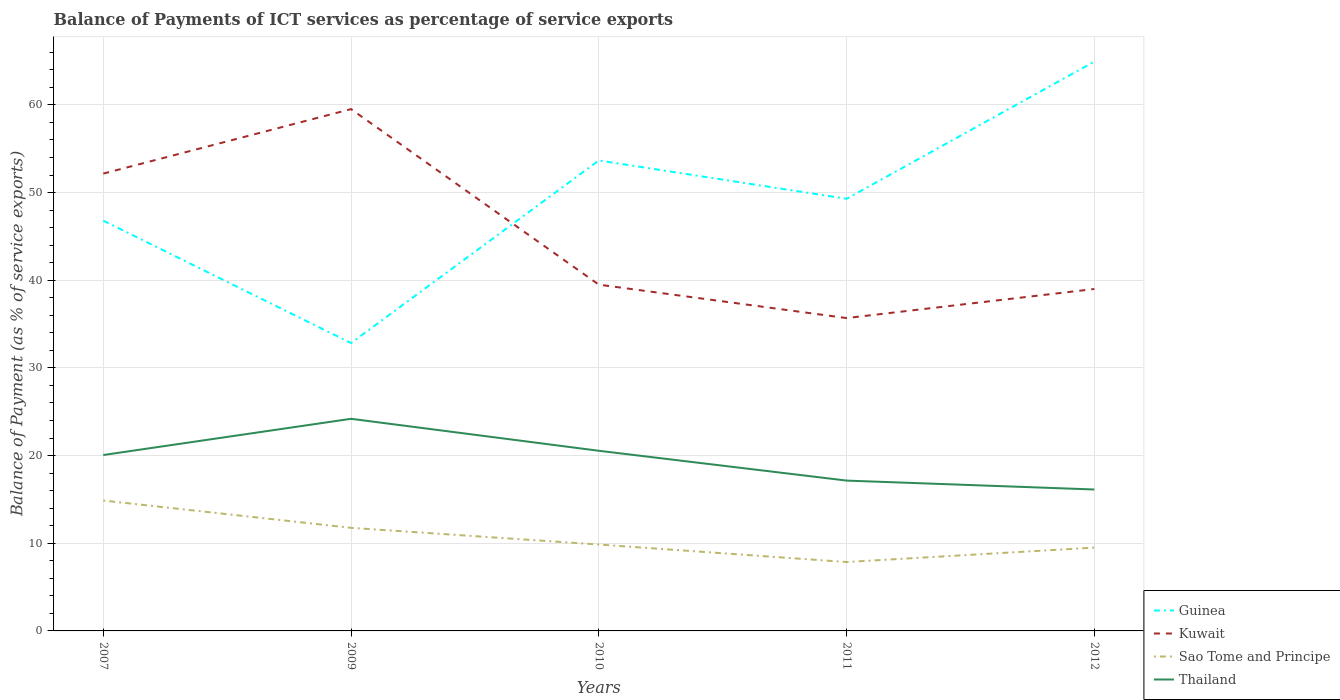How many different coloured lines are there?
Your answer should be compact. 4. Does the line corresponding to Kuwait intersect with the line corresponding to Sao Tome and Principe?
Provide a succinct answer. No. Across all years, what is the maximum balance of payments of ICT services in Kuwait?
Your answer should be very brief. 35.68. What is the total balance of payments of ICT services in Thailand in the graph?
Make the answer very short. -4.13. What is the difference between the highest and the second highest balance of payments of ICT services in Sao Tome and Principe?
Your answer should be compact. 7.01. What is the difference between the highest and the lowest balance of payments of ICT services in Kuwait?
Provide a short and direct response. 2. How many years are there in the graph?
Keep it short and to the point. 5. Does the graph contain any zero values?
Your answer should be compact. No. Where does the legend appear in the graph?
Your answer should be very brief. Bottom right. How many legend labels are there?
Provide a short and direct response. 4. How are the legend labels stacked?
Your response must be concise. Vertical. What is the title of the graph?
Your answer should be very brief. Balance of Payments of ICT services as percentage of service exports. Does "Algeria" appear as one of the legend labels in the graph?
Keep it short and to the point. No. What is the label or title of the Y-axis?
Offer a terse response. Balance of Payment (as % of service exports). What is the Balance of Payment (as % of service exports) in Guinea in 2007?
Your answer should be very brief. 46.8. What is the Balance of Payment (as % of service exports) in Kuwait in 2007?
Your answer should be very brief. 52.16. What is the Balance of Payment (as % of service exports) of Sao Tome and Principe in 2007?
Your answer should be very brief. 14.87. What is the Balance of Payment (as % of service exports) in Thailand in 2007?
Your response must be concise. 20.06. What is the Balance of Payment (as % of service exports) of Guinea in 2009?
Your answer should be very brief. 32.83. What is the Balance of Payment (as % of service exports) of Kuwait in 2009?
Keep it short and to the point. 59.52. What is the Balance of Payment (as % of service exports) of Sao Tome and Principe in 2009?
Your response must be concise. 11.76. What is the Balance of Payment (as % of service exports) in Thailand in 2009?
Ensure brevity in your answer.  24.19. What is the Balance of Payment (as % of service exports) in Guinea in 2010?
Offer a very short reply. 53.66. What is the Balance of Payment (as % of service exports) of Kuwait in 2010?
Your response must be concise. 39.5. What is the Balance of Payment (as % of service exports) in Sao Tome and Principe in 2010?
Offer a terse response. 9.85. What is the Balance of Payment (as % of service exports) in Thailand in 2010?
Make the answer very short. 20.55. What is the Balance of Payment (as % of service exports) in Guinea in 2011?
Your answer should be very brief. 49.29. What is the Balance of Payment (as % of service exports) in Kuwait in 2011?
Ensure brevity in your answer.  35.68. What is the Balance of Payment (as % of service exports) of Sao Tome and Principe in 2011?
Your answer should be compact. 7.86. What is the Balance of Payment (as % of service exports) in Thailand in 2011?
Offer a terse response. 17.15. What is the Balance of Payment (as % of service exports) of Guinea in 2012?
Your response must be concise. 64.94. What is the Balance of Payment (as % of service exports) in Kuwait in 2012?
Offer a terse response. 39. What is the Balance of Payment (as % of service exports) of Sao Tome and Principe in 2012?
Keep it short and to the point. 9.5. What is the Balance of Payment (as % of service exports) in Thailand in 2012?
Offer a terse response. 16.13. Across all years, what is the maximum Balance of Payment (as % of service exports) of Guinea?
Provide a short and direct response. 64.94. Across all years, what is the maximum Balance of Payment (as % of service exports) in Kuwait?
Your answer should be very brief. 59.52. Across all years, what is the maximum Balance of Payment (as % of service exports) of Sao Tome and Principe?
Make the answer very short. 14.87. Across all years, what is the maximum Balance of Payment (as % of service exports) of Thailand?
Offer a terse response. 24.19. Across all years, what is the minimum Balance of Payment (as % of service exports) in Guinea?
Offer a very short reply. 32.83. Across all years, what is the minimum Balance of Payment (as % of service exports) in Kuwait?
Offer a very short reply. 35.68. Across all years, what is the minimum Balance of Payment (as % of service exports) of Sao Tome and Principe?
Keep it short and to the point. 7.86. Across all years, what is the minimum Balance of Payment (as % of service exports) in Thailand?
Offer a very short reply. 16.13. What is the total Balance of Payment (as % of service exports) of Guinea in the graph?
Provide a succinct answer. 247.52. What is the total Balance of Payment (as % of service exports) in Kuwait in the graph?
Your answer should be very brief. 225.86. What is the total Balance of Payment (as % of service exports) in Sao Tome and Principe in the graph?
Provide a succinct answer. 53.85. What is the total Balance of Payment (as % of service exports) of Thailand in the graph?
Your response must be concise. 98.08. What is the difference between the Balance of Payment (as % of service exports) of Guinea in 2007 and that in 2009?
Ensure brevity in your answer.  13.96. What is the difference between the Balance of Payment (as % of service exports) of Kuwait in 2007 and that in 2009?
Offer a very short reply. -7.36. What is the difference between the Balance of Payment (as % of service exports) in Sao Tome and Principe in 2007 and that in 2009?
Your answer should be compact. 3.12. What is the difference between the Balance of Payment (as % of service exports) of Thailand in 2007 and that in 2009?
Your answer should be compact. -4.13. What is the difference between the Balance of Payment (as % of service exports) in Guinea in 2007 and that in 2010?
Offer a terse response. -6.86. What is the difference between the Balance of Payment (as % of service exports) of Kuwait in 2007 and that in 2010?
Your answer should be compact. 12.66. What is the difference between the Balance of Payment (as % of service exports) in Sao Tome and Principe in 2007 and that in 2010?
Ensure brevity in your answer.  5.02. What is the difference between the Balance of Payment (as % of service exports) of Thailand in 2007 and that in 2010?
Your response must be concise. -0.48. What is the difference between the Balance of Payment (as % of service exports) in Guinea in 2007 and that in 2011?
Offer a terse response. -2.49. What is the difference between the Balance of Payment (as % of service exports) of Kuwait in 2007 and that in 2011?
Your answer should be very brief. 16.48. What is the difference between the Balance of Payment (as % of service exports) of Sao Tome and Principe in 2007 and that in 2011?
Give a very brief answer. 7.01. What is the difference between the Balance of Payment (as % of service exports) of Thailand in 2007 and that in 2011?
Ensure brevity in your answer.  2.92. What is the difference between the Balance of Payment (as % of service exports) of Guinea in 2007 and that in 2012?
Your response must be concise. -18.14. What is the difference between the Balance of Payment (as % of service exports) in Kuwait in 2007 and that in 2012?
Offer a terse response. 13.16. What is the difference between the Balance of Payment (as % of service exports) in Sao Tome and Principe in 2007 and that in 2012?
Offer a terse response. 5.37. What is the difference between the Balance of Payment (as % of service exports) in Thailand in 2007 and that in 2012?
Give a very brief answer. 3.93. What is the difference between the Balance of Payment (as % of service exports) of Guinea in 2009 and that in 2010?
Your answer should be very brief. -20.83. What is the difference between the Balance of Payment (as % of service exports) of Kuwait in 2009 and that in 2010?
Provide a succinct answer. 20.02. What is the difference between the Balance of Payment (as % of service exports) of Sao Tome and Principe in 2009 and that in 2010?
Make the answer very short. 1.9. What is the difference between the Balance of Payment (as % of service exports) in Thailand in 2009 and that in 2010?
Offer a very short reply. 3.65. What is the difference between the Balance of Payment (as % of service exports) of Guinea in 2009 and that in 2011?
Provide a short and direct response. -16.45. What is the difference between the Balance of Payment (as % of service exports) in Kuwait in 2009 and that in 2011?
Keep it short and to the point. 23.83. What is the difference between the Balance of Payment (as % of service exports) of Sao Tome and Principe in 2009 and that in 2011?
Offer a very short reply. 3.9. What is the difference between the Balance of Payment (as % of service exports) in Thailand in 2009 and that in 2011?
Keep it short and to the point. 7.05. What is the difference between the Balance of Payment (as % of service exports) in Guinea in 2009 and that in 2012?
Your answer should be compact. -32.1. What is the difference between the Balance of Payment (as % of service exports) of Kuwait in 2009 and that in 2012?
Offer a very short reply. 20.52. What is the difference between the Balance of Payment (as % of service exports) in Sao Tome and Principe in 2009 and that in 2012?
Offer a terse response. 2.25. What is the difference between the Balance of Payment (as % of service exports) of Thailand in 2009 and that in 2012?
Keep it short and to the point. 8.06. What is the difference between the Balance of Payment (as % of service exports) in Guinea in 2010 and that in 2011?
Your answer should be very brief. 4.37. What is the difference between the Balance of Payment (as % of service exports) in Kuwait in 2010 and that in 2011?
Keep it short and to the point. 3.81. What is the difference between the Balance of Payment (as % of service exports) in Sao Tome and Principe in 2010 and that in 2011?
Your answer should be very brief. 1.99. What is the difference between the Balance of Payment (as % of service exports) of Thailand in 2010 and that in 2011?
Offer a terse response. 3.4. What is the difference between the Balance of Payment (as % of service exports) in Guinea in 2010 and that in 2012?
Ensure brevity in your answer.  -11.28. What is the difference between the Balance of Payment (as % of service exports) in Kuwait in 2010 and that in 2012?
Provide a succinct answer. 0.5. What is the difference between the Balance of Payment (as % of service exports) of Sao Tome and Principe in 2010 and that in 2012?
Ensure brevity in your answer.  0.35. What is the difference between the Balance of Payment (as % of service exports) of Thailand in 2010 and that in 2012?
Provide a succinct answer. 4.42. What is the difference between the Balance of Payment (as % of service exports) of Guinea in 2011 and that in 2012?
Keep it short and to the point. -15.65. What is the difference between the Balance of Payment (as % of service exports) in Kuwait in 2011 and that in 2012?
Your response must be concise. -3.32. What is the difference between the Balance of Payment (as % of service exports) of Sao Tome and Principe in 2011 and that in 2012?
Give a very brief answer. -1.64. What is the difference between the Balance of Payment (as % of service exports) in Thailand in 2011 and that in 2012?
Keep it short and to the point. 1.02. What is the difference between the Balance of Payment (as % of service exports) in Guinea in 2007 and the Balance of Payment (as % of service exports) in Kuwait in 2009?
Give a very brief answer. -12.72. What is the difference between the Balance of Payment (as % of service exports) in Guinea in 2007 and the Balance of Payment (as % of service exports) in Sao Tome and Principe in 2009?
Offer a terse response. 35.04. What is the difference between the Balance of Payment (as % of service exports) in Guinea in 2007 and the Balance of Payment (as % of service exports) in Thailand in 2009?
Ensure brevity in your answer.  22.6. What is the difference between the Balance of Payment (as % of service exports) in Kuwait in 2007 and the Balance of Payment (as % of service exports) in Sao Tome and Principe in 2009?
Your answer should be very brief. 40.4. What is the difference between the Balance of Payment (as % of service exports) of Kuwait in 2007 and the Balance of Payment (as % of service exports) of Thailand in 2009?
Provide a succinct answer. 27.97. What is the difference between the Balance of Payment (as % of service exports) of Sao Tome and Principe in 2007 and the Balance of Payment (as % of service exports) of Thailand in 2009?
Your answer should be compact. -9.32. What is the difference between the Balance of Payment (as % of service exports) in Guinea in 2007 and the Balance of Payment (as % of service exports) in Kuwait in 2010?
Keep it short and to the point. 7.3. What is the difference between the Balance of Payment (as % of service exports) of Guinea in 2007 and the Balance of Payment (as % of service exports) of Sao Tome and Principe in 2010?
Your answer should be compact. 36.94. What is the difference between the Balance of Payment (as % of service exports) in Guinea in 2007 and the Balance of Payment (as % of service exports) in Thailand in 2010?
Offer a terse response. 26.25. What is the difference between the Balance of Payment (as % of service exports) in Kuwait in 2007 and the Balance of Payment (as % of service exports) in Sao Tome and Principe in 2010?
Offer a very short reply. 42.31. What is the difference between the Balance of Payment (as % of service exports) in Kuwait in 2007 and the Balance of Payment (as % of service exports) in Thailand in 2010?
Offer a terse response. 31.61. What is the difference between the Balance of Payment (as % of service exports) in Sao Tome and Principe in 2007 and the Balance of Payment (as % of service exports) in Thailand in 2010?
Provide a short and direct response. -5.67. What is the difference between the Balance of Payment (as % of service exports) in Guinea in 2007 and the Balance of Payment (as % of service exports) in Kuwait in 2011?
Ensure brevity in your answer.  11.11. What is the difference between the Balance of Payment (as % of service exports) in Guinea in 2007 and the Balance of Payment (as % of service exports) in Sao Tome and Principe in 2011?
Keep it short and to the point. 38.94. What is the difference between the Balance of Payment (as % of service exports) in Guinea in 2007 and the Balance of Payment (as % of service exports) in Thailand in 2011?
Provide a succinct answer. 29.65. What is the difference between the Balance of Payment (as % of service exports) in Kuwait in 2007 and the Balance of Payment (as % of service exports) in Sao Tome and Principe in 2011?
Your answer should be compact. 44.3. What is the difference between the Balance of Payment (as % of service exports) of Kuwait in 2007 and the Balance of Payment (as % of service exports) of Thailand in 2011?
Your answer should be very brief. 35.01. What is the difference between the Balance of Payment (as % of service exports) in Sao Tome and Principe in 2007 and the Balance of Payment (as % of service exports) in Thailand in 2011?
Your answer should be very brief. -2.27. What is the difference between the Balance of Payment (as % of service exports) in Guinea in 2007 and the Balance of Payment (as % of service exports) in Kuwait in 2012?
Provide a succinct answer. 7.8. What is the difference between the Balance of Payment (as % of service exports) in Guinea in 2007 and the Balance of Payment (as % of service exports) in Sao Tome and Principe in 2012?
Offer a very short reply. 37.29. What is the difference between the Balance of Payment (as % of service exports) in Guinea in 2007 and the Balance of Payment (as % of service exports) in Thailand in 2012?
Ensure brevity in your answer.  30.67. What is the difference between the Balance of Payment (as % of service exports) of Kuwait in 2007 and the Balance of Payment (as % of service exports) of Sao Tome and Principe in 2012?
Offer a very short reply. 42.66. What is the difference between the Balance of Payment (as % of service exports) in Kuwait in 2007 and the Balance of Payment (as % of service exports) in Thailand in 2012?
Make the answer very short. 36.03. What is the difference between the Balance of Payment (as % of service exports) of Sao Tome and Principe in 2007 and the Balance of Payment (as % of service exports) of Thailand in 2012?
Offer a terse response. -1.26. What is the difference between the Balance of Payment (as % of service exports) in Guinea in 2009 and the Balance of Payment (as % of service exports) in Kuwait in 2010?
Your answer should be compact. -6.66. What is the difference between the Balance of Payment (as % of service exports) of Guinea in 2009 and the Balance of Payment (as % of service exports) of Sao Tome and Principe in 2010?
Provide a short and direct response. 22.98. What is the difference between the Balance of Payment (as % of service exports) of Guinea in 2009 and the Balance of Payment (as % of service exports) of Thailand in 2010?
Ensure brevity in your answer.  12.29. What is the difference between the Balance of Payment (as % of service exports) of Kuwait in 2009 and the Balance of Payment (as % of service exports) of Sao Tome and Principe in 2010?
Your answer should be very brief. 49.66. What is the difference between the Balance of Payment (as % of service exports) of Kuwait in 2009 and the Balance of Payment (as % of service exports) of Thailand in 2010?
Keep it short and to the point. 38.97. What is the difference between the Balance of Payment (as % of service exports) in Sao Tome and Principe in 2009 and the Balance of Payment (as % of service exports) in Thailand in 2010?
Your answer should be compact. -8.79. What is the difference between the Balance of Payment (as % of service exports) in Guinea in 2009 and the Balance of Payment (as % of service exports) in Kuwait in 2011?
Provide a succinct answer. -2.85. What is the difference between the Balance of Payment (as % of service exports) of Guinea in 2009 and the Balance of Payment (as % of service exports) of Sao Tome and Principe in 2011?
Your response must be concise. 24.98. What is the difference between the Balance of Payment (as % of service exports) of Guinea in 2009 and the Balance of Payment (as % of service exports) of Thailand in 2011?
Your response must be concise. 15.69. What is the difference between the Balance of Payment (as % of service exports) of Kuwait in 2009 and the Balance of Payment (as % of service exports) of Sao Tome and Principe in 2011?
Provide a short and direct response. 51.66. What is the difference between the Balance of Payment (as % of service exports) of Kuwait in 2009 and the Balance of Payment (as % of service exports) of Thailand in 2011?
Ensure brevity in your answer.  42.37. What is the difference between the Balance of Payment (as % of service exports) in Sao Tome and Principe in 2009 and the Balance of Payment (as % of service exports) in Thailand in 2011?
Your answer should be compact. -5.39. What is the difference between the Balance of Payment (as % of service exports) of Guinea in 2009 and the Balance of Payment (as % of service exports) of Kuwait in 2012?
Ensure brevity in your answer.  -6.17. What is the difference between the Balance of Payment (as % of service exports) of Guinea in 2009 and the Balance of Payment (as % of service exports) of Sao Tome and Principe in 2012?
Offer a very short reply. 23.33. What is the difference between the Balance of Payment (as % of service exports) of Guinea in 2009 and the Balance of Payment (as % of service exports) of Thailand in 2012?
Keep it short and to the point. 16.7. What is the difference between the Balance of Payment (as % of service exports) of Kuwait in 2009 and the Balance of Payment (as % of service exports) of Sao Tome and Principe in 2012?
Keep it short and to the point. 50.01. What is the difference between the Balance of Payment (as % of service exports) of Kuwait in 2009 and the Balance of Payment (as % of service exports) of Thailand in 2012?
Offer a very short reply. 43.39. What is the difference between the Balance of Payment (as % of service exports) in Sao Tome and Principe in 2009 and the Balance of Payment (as % of service exports) in Thailand in 2012?
Offer a very short reply. -4.37. What is the difference between the Balance of Payment (as % of service exports) in Guinea in 2010 and the Balance of Payment (as % of service exports) in Kuwait in 2011?
Your answer should be compact. 17.98. What is the difference between the Balance of Payment (as % of service exports) of Guinea in 2010 and the Balance of Payment (as % of service exports) of Sao Tome and Principe in 2011?
Your response must be concise. 45.8. What is the difference between the Balance of Payment (as % of service exports) of Guinea in 2010 and the Balance of Payment (as % of service exports) of Thailand in 2011?
Offer a terse response. 36.51. What is the difference between the Balance of Payment (as % of service exports) of Kuwait in 2010 and the Balance of Payment (as % of service exports) of Sao Tome and Principe in 2011?
Ensure brevity in your answer.  31.64. What is the difference between the Balance of Payment (as % of service exports) in Kuwait in 2010 and the Balance of Payment (as % of service exports) in Thailand in 2011?
Provide a short and direct response. 22.35. What is the difference between the Balance of Payment (as % of service exports) of Sao Tome and Principe in 2010 and the Balance of Payment (as % of service exports) of Thailand in 2011?
Your response must be concise. -7.29. What is the difference between the Balance of Payment (as % of service exports) of Guinea in 2010 and the Balance of Payment (as % of service exports) of Kuwait in 2012?
Make the answer very short. 14.66. What is the difference between the Balance of Payment (as % of service exports) in Guinea in 2010 and the Balance of Payment (as % of service exports) in Sao Tome and Principe in 2012?
Offer a terse response. 44.16. What is the difference between the Balance of Payment (as % of service exports) of Guinea in 2010 and the Balance of Payment (as % of service exports) of Thailand in 2012?
Your response must be concise. 37.53. What is the difference between the Balance of Payment (as % of service exports) in Kuwait in 2010 and the Balance of Payment (as % of service exports) in Sao Tome and Principe in 2012?
Your answer should be compact. 29.99. What is the difference between the Balance of Payment (as % of service exports) of Kuwait in 2010 and the Balance of Payment (as % of service exports) of Thailand in 2012?
Provide a short and direct response. 23.37. What is the difference between the Balance of Payment (as % of service exports) in Sao Tome and Principe in 2010 and the Balance of Payment (as % of service exports) in Thailand in 2012?
Offer a very short reply. -6.28. What is the difference between the Balance of Payment (as % of service exports) in Guinea in 2011 and the Balance of Payment (as % of service exports) in Kuwait in 2012?
Offer a very short reply. 10.29. What is the difference between the Balance of Payment (as % of service exports) in Guinea in 2011 and the Balance of Payment (as % of service exports) in Sao Tome and Principe in 2012?
Give a very brief answer. 39.79. What is the difference between the Balance of Payment (as % of service exports) in Guinea in 2011 and the Balance of Payment (as % of service exports) in Thailand in 2012?
Your answer should be compact. 33.16. What is the difference between the Balance of Payment (as % of service exports) of Kuwait in 2011 and the Balance of Payment (as % of service exports) of Sao Tome and Principe in 2012?
Offer a terse response. 26.18. What is the difference between the Balance of Payment (as % of service exports) of Kuwait in 2011 and the Balance of Payment (as % of service exports) of Thailand in 2012?
Your answer should be compact. 19.55. What is the difference between the Balance of Payment (as % of service exports) of Sao Tome and Principe in 2011 and the Balance of Payment (as % of service exports) of Thailand in 2012?
Provide a short and direct response. -8.27. What is the average Balance of Payment (as % of service exports) of Guinea per year?
Offer a very short reply. 49.5. What is the average Balance of Payment (as % of service exports) of Kuwait per year?
Offer a terse response. 45.17. What is the average Balance of Payment (as % of service exports) of Sao Tome and Principe per year?
Provide a short and direct response. 10.77. What is the average Balance of Payment (as % of service exports) of Thailand per year?
Keep it short and to the point. 19.62. In the year 2007, what is the difference between the Balance of Payment (as % of service exports) of Guinea and Balance of Payment (as % of service exports) of Kuwait?
Keep it short and to the point. -5.36. In the year 2007, what is the difference between the Balance of Payment (as % of service exports) in Guinea and Balance of Payment (as % of service exports) in Sao Tome and Principe?
Ensure brevity in your answer.  31.92. In the year 2007, what is the difference between the Balance of Payment (as % of service exports) of Guinea and Balance of Payment (as % of service exports) of Thailand?
Keep it short and to the point. 26.73. In the year 2007, what is the difference between the Balance of Payment (as % of service exports) in Kuwait and Balance of Payment (as % of service exports) in Sao Tome and Principe?
Your answer should be compact. 37.29. In the year 2007, what is the difference between the Balance of Payment (as % of service exports) in Kuwait and Balance of Payment (as % of service exports) in Thailand?
Provide a short and direct response. 32.1. In the year 2007, what is the difference between the Balance of Payment (as % of service exports) of Sao Tome and Principe and Balance of Payment (as % of service exports) of Thailand?
Provide a succinct answer. -5.19. In the year 2009, what is the difference between the Balance of Payment (as % of service exports) of Guinea and Balance of Payment (as % of service exports) of Kuwait?
Your answer should be compact. -26.68. In the year 2009, what is the difference between the Balance of Payment (as % of service exports) in Guinea and Balance of Payment (as % of service exports) in Sao Tome and Principe?
Offer a very short reply. 21.08. In the year 2009, what is the difference between the Balance of Payment (as % of service exports) in Guinea and Balance of Payment (as % of service exports) in Thailand?
Your answer should be very brief. 8.64. In the year 2009, what is the difference between the Balance of Payment (as % of service exports) of Kuwait and Balance of Payment (as % of service exports) of Sao Tome and Principe?
Offer a terse response. 47.76. In the year 2009, what is the difference between the Balance of Payment (as % of service exports) in Kuwait and Balance of Payment (as % of service exports) in Thailand?
Provide a succinct answer. 35.32. In the year 2009, what is the difference between the Balance of Payment (as % of service exports) of Sao Tome and Principe and Balance of Payment (as % of service exports) of Thailand?
Make the answer very short. -12.44. In the year 2010, what is the difference between the Balance of Payment (as % of service exports) of Guinea and Balance of Payment (as % of service exports) of Kuwait?
Your answer should be compact. 14.16. In the year 2010, what is the difference between the Balance of Payment (as % of service exports) of Guinea and Balance of Payment (as % of service exports) of Sao Tome and Principe?
Make the answer very short. 43.81. In the year 2010, what is the difference between the Balance of Payment (as % of service exports) in Guinea and Balance of Payment (as % of service exports) in Thailand?
Make the answer very short. 33.11. In the year 2010, what is the difference between the Balance of Payment (as % of service exports) in Kuwait and Balance of Payment (as % of service exports) in Sao Tome and Principe?
Your response must be concise. 29.64. In the year 2010, what is the difference between the Balance of Payment (as % of service exports) in Kuwait and Balance of Payment (as % of service exports) in Thailand?
Offer a very short reply. 18.95. In the year 2010, what is the difference between the Balance of Payment (as % of service exports) of Sao Tome and Principe and Balance of Payment (as % of service exports) of Thailand?
Give a very brief answer. -10.69. In the year 2011, what is the difference between the Balance of Payment (as % of service exports) in Guinea and Balance of Payment (as % of service exports) in Kuwait?
Provide a succinct answer. 13.61. In the year 2011, what is the difference between the Balance of Payment (as % of service exports) in Guinea and Balance of Payment (as % of service exports) in Sao Tome and Principe?
Your answer should be compact. 41.43. In the year 2011, what is the difference between the Balance of Payment (as % of service exports) of Guinea and Balance of Payment (as % of service exports) of Thailand?
Ensure brevity in your answer.  32.14. In the year 2011, what is the difference between the Balance of Payment (as % of service exports) of Kuwait and Balance of Payment (as % of service exports) of Sao Tome and Principe?
Your answer should be compact. 27.82. In the year 2011, what is the difference between the Balance of Payment (as % of service exports) of Kuwait and Balance of Payment (as % of service exports) of Thailand?
Your answer should be very brief. 18.54. In the year 2011, what is the difference between the Balance of Payment (as % of service exports) in Sao Tome and Principe and Balance of Payment (as % of service exports) in Thailand?
Offer a terse response. -9.29. In the year 2012, what is the difference between the Balance of Payment (as % of service exports) of Guinea and Balance of Payment (as % of service exports) of Kuwait?
Keep it short and to the point. 25.94. In the year 2012, what is the difference between the Balance of Payment (as % of service exports) of Guinea and Balance of Payment (as % of service exports) of Sao Tome and Principe?
Offer a very short reply. 55.43. In the year 2012, what is the difference between the Balance of Payment (as % of service exports) of Guinea and Balance of Payment (as % of service exports) of Thailand?
Keep it short and to the point. 48.81. In the year 2012, what is the difference between the Balance of Payment (as % of service exports) in Kuwait and Balance of Payment (as % of service exports) in Sao Tome and Principe?
Offer a very short reply. 29.5. In the year 2012, what is the difference between the Balance of Payment (as % of service exports) in Kuwait and Balance of Payment (as % of service exports) in Thailand?
Your answer should be compact. 22.87. In the year 2012, what is the difference between the Balance of Payment (as % of service exports) in Sao Tome and Principe and Balance of Payment (as % of service exports) in Thailand?
Make the answer very short. -6.63. What is the ratio of the Balance of Payment (as % of service exports) in Guinea in 2007 to that in 2009?
Provide a short and direct response. 1.43. What is the ratio of the Balance of Payment (as % of service exports) in Kuwait in 2007 to that in 2009?
Your response must be concise. 0.88. What is the ratio of the Balance of Payment (as % of service exports) of Sao Tome and Principe in 2007 to that in 2009?
Provide a succinct answer. 1.26. What is the ratio of the Balance of Payment (as % of service exports) in Thailand in 2007 to that in 2009?
Offer a very short reply. 0.83. What is the ratio of the Balance of Payment (as % of service exports) of Guinea in 2007 to that in 2010?
Make the answer very short. 0.87. What is the ratio of the Balance of Payment (as % of service exports) of Kuwait in 2007 to that in 2010?
Your answer should be very brief. 1.32. What is the ratio of the Balance of Payment (as % of service exports) of Sao Tome and Principe in 2007 to that in 2010?
Provide a short and direct response. 1.51. What is the ratio of the Balance of Payment (as % of service exports) in Thailand in 2007 to that in 2010?
Keep it short and to the point. 0.98. What is the ratio of the Balance of Payment (as % of service exports) in Guinea in 2007 to that in 2011?
Provide a succinct answer. 0.95. What is the ratio of the Balance of Payment (as % of service exports) of Kuwait in 2007 to that in 2011?
Ensure brevity in your answer.  1.46. What is the ratio of the Balance of Payment (as % of service exports) in Sao Tome and Principe in 2007 to that in 2011?
Offer a terse response. 1.89. What is the ratio of the Balance of Payment (as % of service exports) in Thailand in 2007 to that in 2011?
Your answer should be very brief. 1.17. What is the ratio of the Balance of Payment (as % of service exports) of Guinea in 2007 to that in 2012?
Give a very brief answer. 0.72. What is the ratio of the Balance of Payment (as % of service exports) in Kuwait in 2007 to that in 2012?
Keep it short and to the point. 1.34. What is the ratio of the Balance of Payment (as % of service exports) in Sao Tome and Principe in 2007 to that in 2012?
Offer a terse response. 1.56. What is the ratio of the Balance of Payment (as % of service exports) in Thailand in 2007 to that in 2012?
Your answer should be compact. 1.24. What is the ratio of the Balance of Payment (as % of service exports) in Guinea in 2009 to that in 2010?
Offer a terse response. 0.61. What is the ratio of the Balance of Payment (as % of service exports) in Kuwait in 2009 to that in 2010?
Provide a succinct answer. 1.51. What is the ratio of the Balance of Payment (as % of service exports) in Sao Tome and Principe in 2009 to that in 2010?
Provide a short and direct response. 1.19. What is the ratio of the Balance of Payment (as % of service exports) in Thailand in 2009 to that in 2010?
Give a very brief answer. 1.18. What is the ratio of the Balance of Payment (as % of service exports) of Guinea in 2009 to that in 2011?
Make the answer very short. 0.67. What is the ratio of the Balance of Payment (as % of service exports) of Kuwait in 2009 to that in 2011?
Your answer should be compact. 1.67. What is the ratio of the Balance of Payment (as % of service exports) of Sao Tome and Principe in 2009 to that in 2011?
Offer a terse response. 1.5. What is the ratio of the Balance of Payment (as % of service exports) in Thailand in 2009 to that in 2011?
Provide a short and direct response. 1.41. What is the ratio of the Balance of Payment (as % of service exports) in Guinea in 2009 to that in 2012?
Provide a succinct answer. 0.51. What is the ratio of the Balance of Payment (as % of service exports) of Kuwait in 2009 to that in 2012?
Provide a short and direct response. 1.53. What is the ratio of the Balance of Payment (as % of service exports) of Sao Tome and Principe in 2009 to that in 2012?
Keep it short and to the point. 1.24. What is the ratio of the Balance of Payment (as % of service exports) in Thailand in 2009 to that in 2012?
Your answer should be very brief. 1.5. What is the ratio of the Balance of Payment (as % of service exports) of Guinea in 2010 to that in 2011?
Your response must be concise. 1.09. What is the ratio of the Balance of Payment (as % of service exports) of Kuwait in 2010 to that in 2011?
Your answer should be compact. 1.11. What is the ratio of the Balance of Payment (as % of service exports) of Sao Tome and Principe in 2010 to that in 2011?
Offer a terse response. 1.25. What is the ratio of the Balance of Payment (as % of service exports) in Thailand in 2010 to that in 2011?
Your answer should be compact. 1.2. What is the ratio of the Balance of Payment (as % of service exports) in Guinea in 2010 to that in 2012?
Make the answer very short. 0.83. What is the ratio of the Balance of Payment (as % of service exports) in Kuwait in 2010 to that in 2012?
Your answer should be very brief. 1.01. What is the ratio of the Balance of Payment (as % of service exports) of Sao Tome and Principe in 2010 to that in 2012?
Give a very brief answer. 1.04. What is the ratio of the Balance of Payment (as % of service exports) of Thailand in 2010 to that in 2012?
Ensure brevity in your answer.  1.27. What is the ratio of the Balance of Payment (as % of service exports) in Guinea in 2011 to that in 2012?
Your response must be concise. 0.76. What is the ratio of the Balance of Payment (as % of service exports) of Kuwait in 2011 to that in 2012?
Provide a succinct answer. 0.92. What is the ratio of the Balance of Payment (as % of service exports) in Sao Tome and Principe in 2011 to that in 2012?
Your answer should be compact. 0.83. What is the ratio of the Balance of Payment (as % of service exports) in Thailand in 2011 to that in 2012?
Offer a terse response. 1.06. What is the difference between the highest and the second highest Balance of Payment (as % of service exports) of Guinea?
Keep it short and to the point. 11.28. What is the difference between the highest and the second highest Balance of Payment (as % of service exports) in Kuwait?
Ensure brevity in your answer.  7.36. What is the difference between the highest and the second highest Balance of Payment (as % of service exports) of Sao Tome and Principe?
Offer a terse response. 3.12. What is the difference between the highest and the second highest Balance of Payment (as % of service exports) in Thailand?
Your answer should be very brief. 3.65. What is the difference between the highest and the lowest Balance of Payment (as % of service exports) of Guinea?
Offer a very short reply. 32.1. What is the difference between the highest and the lowest Balance of Payment (as % of service exports) in Kuwait?
Your answer should be compact. 23.83. What is the difference between the highest and the lowest Balance of Payment (as % of service exports) in Sao Tome and Principe?
Ensure brevity in your answer.  7.01. What is the difference between the highest and the lowest Balance of Payment (as % of service exports) of Thailand?
Provide a short and direct response. 8.06. 